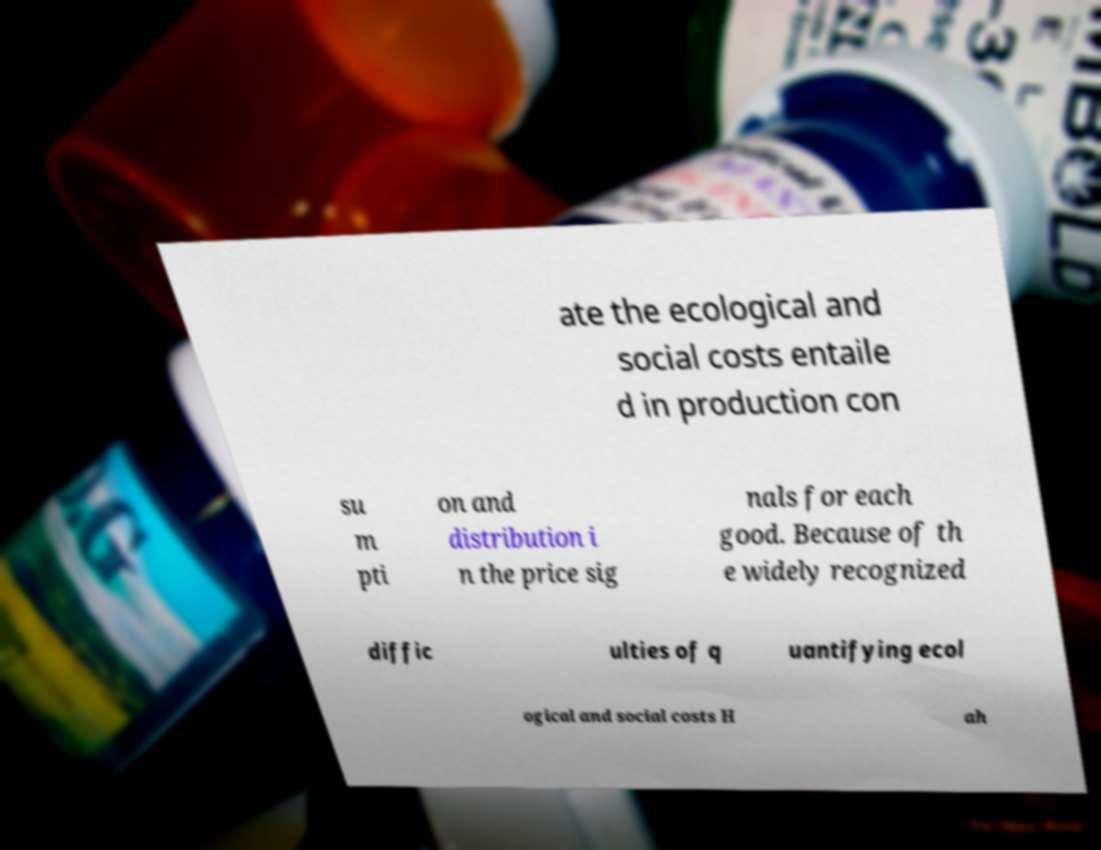Please identify and transcribe the text found in this image. ate the ecological and social costs entaile d in production con su m pti on and distribution i n the price sig nals for each good. Because of th e widely recognized diffic ulties of q uantifying ecol ogical and social costs H ah 